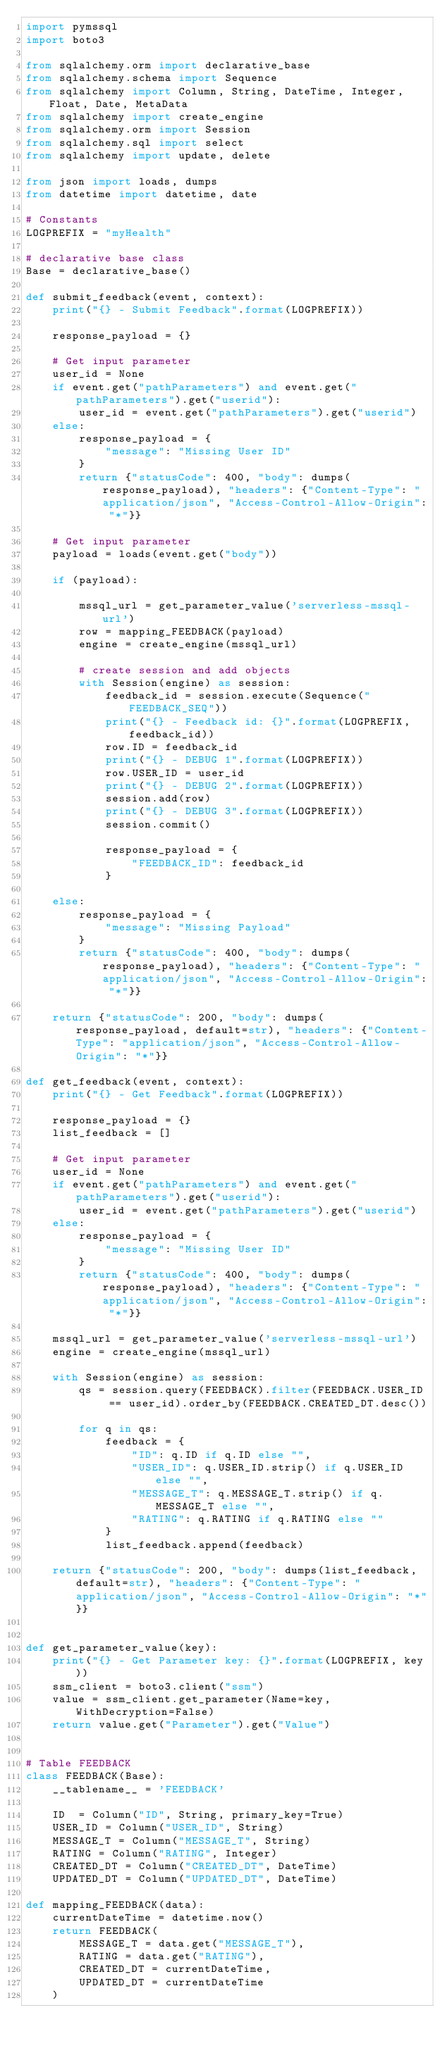<code> <loc_0><loc_0><loc_500><loc_500><_Python_>import pymssql
import boto3

from sqlalchemy.orm import declarative_base
from sqlalchemy.schema import Sequence
from sqlalchemy import Column, String, DateTime, Integer, Float, Date, MetaData
from sqlalchemy import create_engine
from sqlalchemy.orm import Session
from sqlalchemy.sql import select
from sqlalchemy import update, delete

from json import loads, dumps
from datetime import datetime, date

# Constants
LOGPREFIX = "myHealth"

# declarative base class
Base = declarative_base()

def submit_feedback(event, context):
    print("{} - Submit Feedback".format(LOGPREFIX))
    
    response_payload = {}
    
    # Get input parameter
    user_id = None
    if event.get("pathParameters") and event.get("pathParameters").get("userid"):
        user_id = event.get("pathParameters").get("userid")
    else:
        response_payload = {
            "message": "Missing User ID"
        }
        return {"statusCode": 400, "body": dumps(response_payload), "headers": {"Content-Type": "application/json", "Access-Control-Allow-Origin": "*"}}
    
    # Get input parameter
    payload = loads(event.get("body"))
    
    if (payload):
        
        mssql_url = get_parameter_value('serverless-mssql-url')
        row = mapping_FEEDBACK(payload)
        engine = create_engine(mssql_url)

        # create session and add objects
        with Session(engine) as session:
            feedback_id = session.execute(Sequence("FEEDBACK_SEQ"))
            print("{} - Feedback id: {}".format(LOGPREFIX, feedback_id))
            row.ID = feedback_id
            print("{} - DEBUG 1".format(LOGPREFIX))
            row.USER_ID = user_id
            print("{} - DEBUG 2".format(LOGPREFIX))
            session.add(row)
            print("{} - DEBUG 3".format(LOGPREFIX))
            session.commit()
            
            response_payload = {
                "FEEDBACK_ID": feedback_id
            }
            
    else:
        response_payload = {
            "message": "Missing Payload"
        }
        return {"statusCode": 400, "body": dumps(response_payload), "headers": {"Content-Type": "application/json", "Access-Control-Allow-Origin": "*"}}
        
    return {"statusCode": 200, "body": dumps(response_payload, default=str), "headers": {"Content-Type": "application/json", "Access-Control-Allow-Origin": "*"}}
    
def get_feedback(event, context):
    print("{} - Get Feedback".format(LOGPREFIX))
    
    response_payload = {}
    list_feedback = []
    
    # Get input parameter
    user_id = None
    if event.get("pathParameters") and event.get("pathParameters").get("userid"):
        user_id = event.get("pathParameters").get("userid")
    else:
        response_payload = {
            "message": "Missing User ID"
        }
        return {"statusCode": 400, "body": dumps(response_payload), "headers": {"Content-Type": "application/json", "Access-Control-Allow-Origin": "*"}}
    
    mssql_url = get_parameter_value('serverless-mssql-url')
    engine = create_engine(mssql_url)
    
    with Session(engine) as session:
        qs = session.query(FEEDBACK).filter(FEEDBACK.USER_ID == user_id).order_by(FEEDBACK.CREATED_DT.desc())
        
        for q in qs:
            feedback = {
                "ID": q.ID if q.ID else "",
                "USER_ID": q.USER_ID.strip() if q.USER_ID else "",
                "MESSAGE_T": q.MESSAGE_T.strip() if q.MESSAGE_T else "",
                "RATING": q.RATING if q.RATING else ""
            }
            list_feedback.append(feedback)
            
    return {"statusCode": 200, "body": dumps(list_feedback, default=str), "headers": {"Content-Type": "application/json", "Access-Control-Allow-Origin": "*"}}
    
    
def get_parameter_value(key):
    print("{} - Get Parameter key: {}".format(LOGPREFIX, key))
    ssm_client = boto3.client("ssm")
    value = ssm_client.get_parameter(Name=key, WithDecryption=False)
    return value.get("Parameter").get("Value")


# Table FEEDBACK
class FEEDBACK(Base):
    __tablename__ = 'FEEDBACK'
    
    ID  = Column("ID", String, primary_key=True)
    USER_ID = Column("USER_ID", String)
    MESSAGE_T = Column("MESSAGE_T", String)
    RATING = Column("RATING", Integer)
    CREATED_DT = Column("CREATED_DT", DateTime)
    UPDATED_DT = Column("UPDATED_DT", DateTime)
    
def mapping_FEEDBACK(data):
    currentDateTime = datetime.now()
    return FEEDBACK(
        MESSAGE_T = data.get("MESSAGE_T"),
        RATING = data.get("RATING"),
        CREATED_DT = currentDateTime,
        UPDATED_DT = currentDateTime
    )
    </code> 